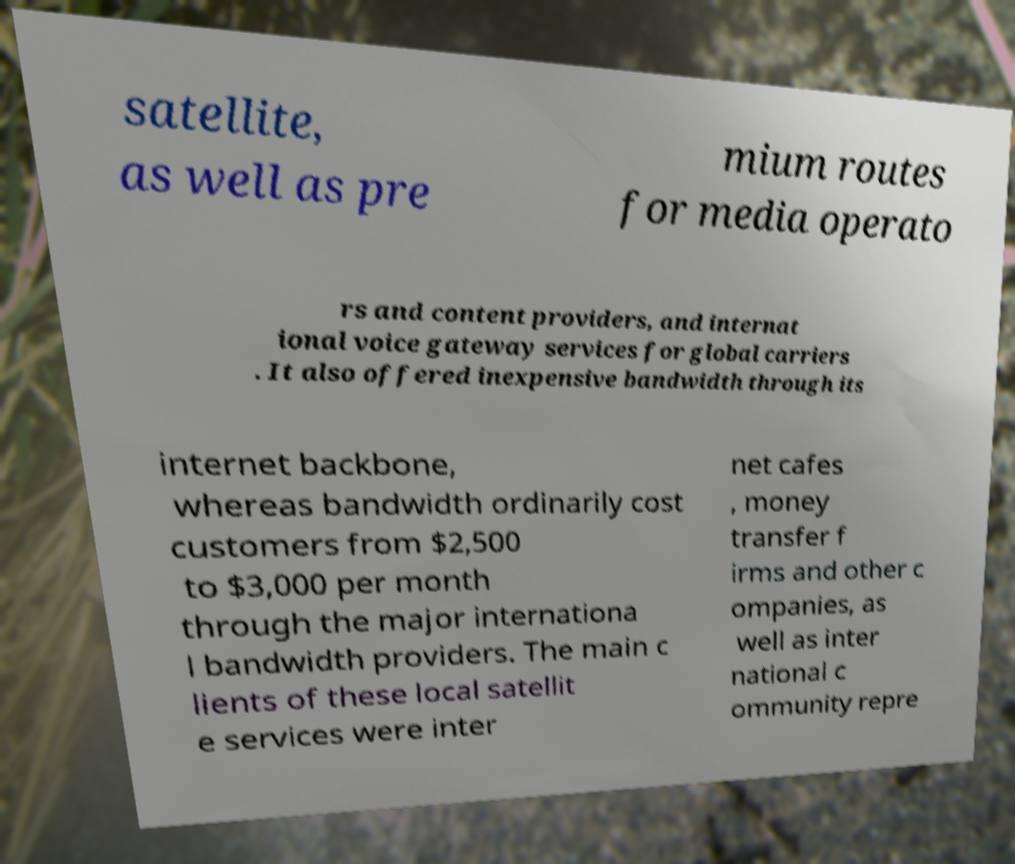Could you extract and type out the text from this image? satellite, as well as pre mium routes for media operato rs and content providers, and internat ional voice gateway services for global carriers . It also offered inexpensive bandwidth through its internet backbone, whereas bandwidth ordinarily cost customers from $2,500 to $3,000 per month through the major internationa l bandwidth providers. The main c lients of these local satellit e services were inter net cafes , money transfer f irms and other c ompanies, as well as inter national c ommunity repre 